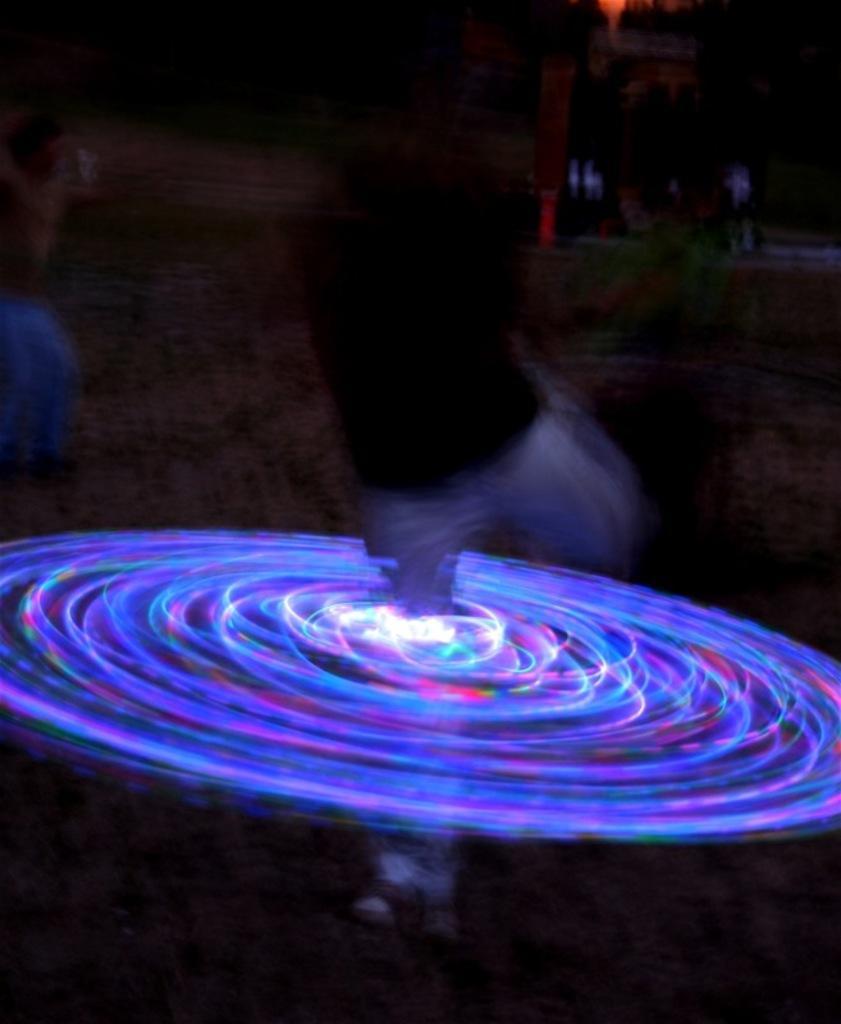How would you summarize this image in a sentence or two? It is a blur image. In the image there is a person. Around the person's legs there are lights in round shape. 